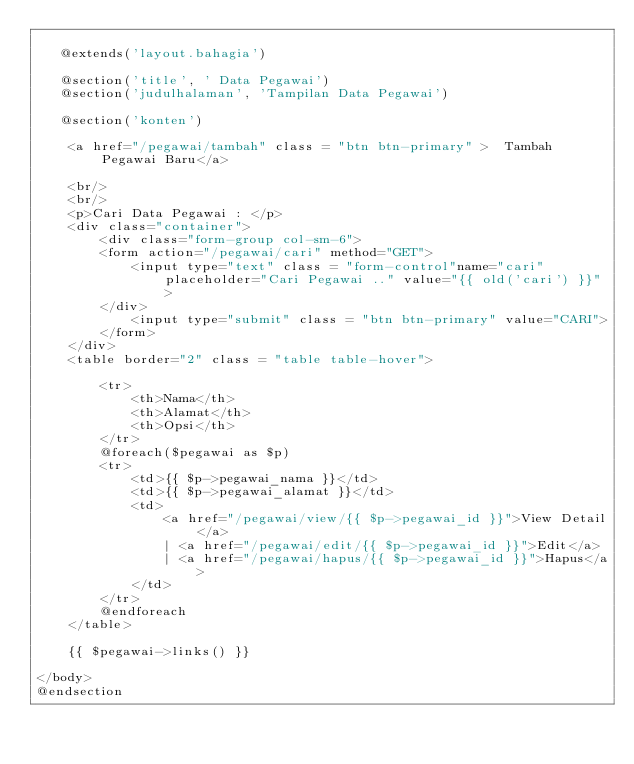Convert code to text. <code><loc_0><loc_0><loc_500><loc_500><_PHP_>
   @extends('layout.bahagia')

   @section('title', ' Data Pegawai')
   @section('judulhalaman', 'Tampilan Data Pegawai')

   @section('konten')

	<a href="/pegawai/tambah" class = "btn btn-primary" >  Tambah Pegawai Baru</a>

	<br/>
	<br/>
    <p>Cari Data Pegawai : </p>
    <div class="container">
        <div class="form-group col-sm-6">
        <form action="/pegawai/cari" method="GET">
            <input type="text" class = "form-control"name="cari" placeholder="Cari Pegawai .." value="{{ old('cari') }}">
        </div>
            <input type="submit" class = "btn btn-primary" value="CARI">
        </form>
    </div>
	<table border="2" class = "table table-hover">

		<tr>
			<th>Nama</th>
			<th>Alamat</th>
			<th>Opsi</th>
		</tr>
		@foreach($pegawai as $p)
		<tr>
			<td>{{ $p->pegawai_nama }}</td>
			<td>{{ $p->pegawai_alamat }}</td>
			<td>
				<a href="/pegawai/view/{{ $p->pegawai_id }}">View Detail</a>
				| <a href="/pegawai/edit/{{ $p->pegawai_id }}">Edit</a>
                | <a href="/pegawai/hapus/{{ $p->pegawai_id }}">Hapus</a>
			</td>
		</tr>
		@endforeach
	</table>

    {{ $pegawai->links() }}

</body>
@endsection
</code> 